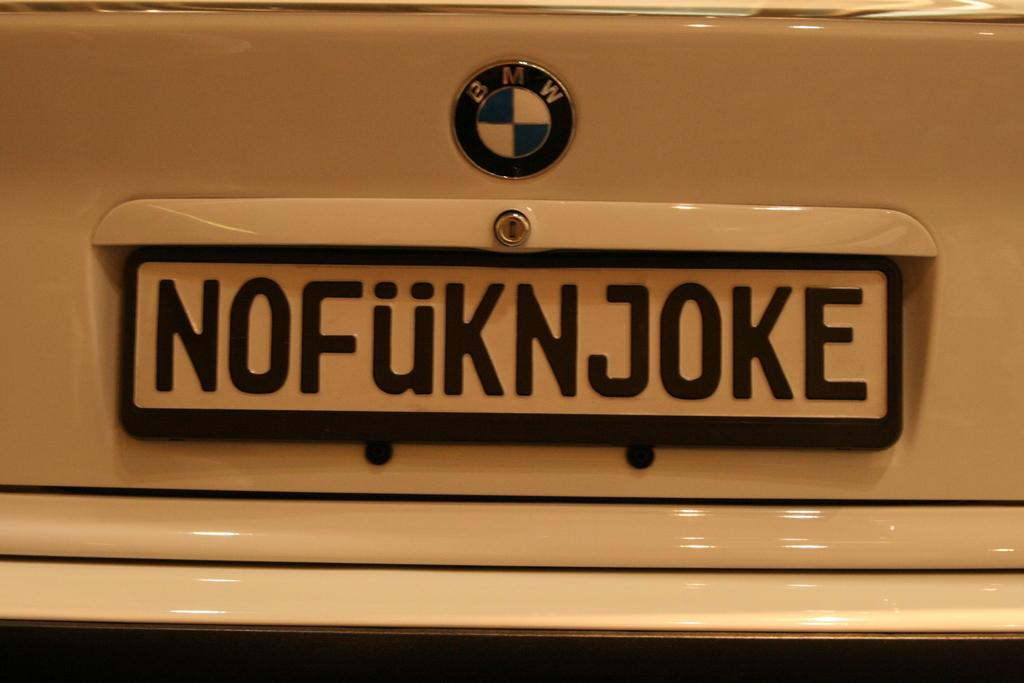Provide a one-sentence caption for the provided image. The licence plate of a BMW that says NOFUKNJOKE. 